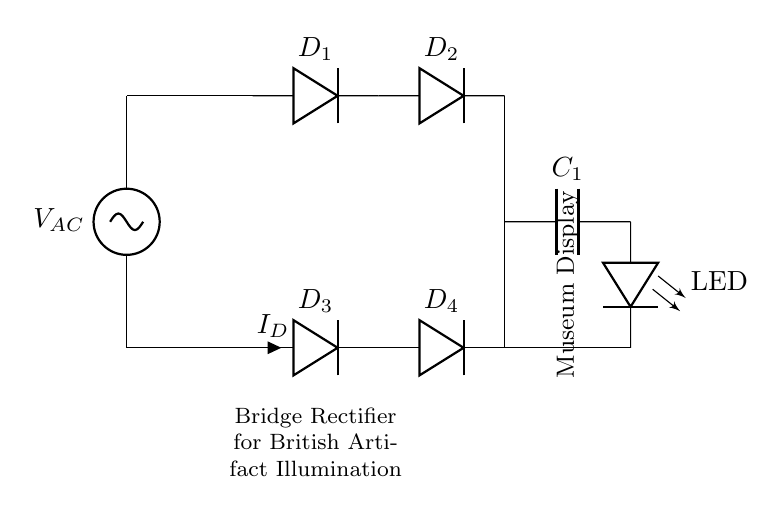What type of rectifier is used in this circuit? The circuit diagram depicts a bridge rectifier, characterized by the arrangement of four diodes connected in a bridge configuration to convert AC to DC.
Answer: bridge rectifier How many diodes are in the bridge rectifier? There are four diodes situated in the bridge rectifier section of the circuit, designated as D1, D2, D3, and D4.
Answer: four What component is used to smooth the output voltage? The smoothing capacitor labeled C1 is connected in parallel with the load to help reduce voltage ripple after rectification.
Answer: C1 What is the load in this circuit? The load is an LED, referred to in the diagram, which will illuminate when the DC voltage is supplied to it.
Answer: LED What is the function of the component labeled D3? D3, like the other diodes, serves to allow current to flow in one direction, facilitating the rectification process by conducting during one half-cycle of the AC voltage.
Answer: rectification Why is a bridge rectifier preferred for LED illumination? A bridge rectifier provides full-wave rectification, utilizing both halves of the AC waveform, resulting in a smoother and more efficient power delivery for LEDs compared to half-wave rectifiers.
Answer: efficiency 